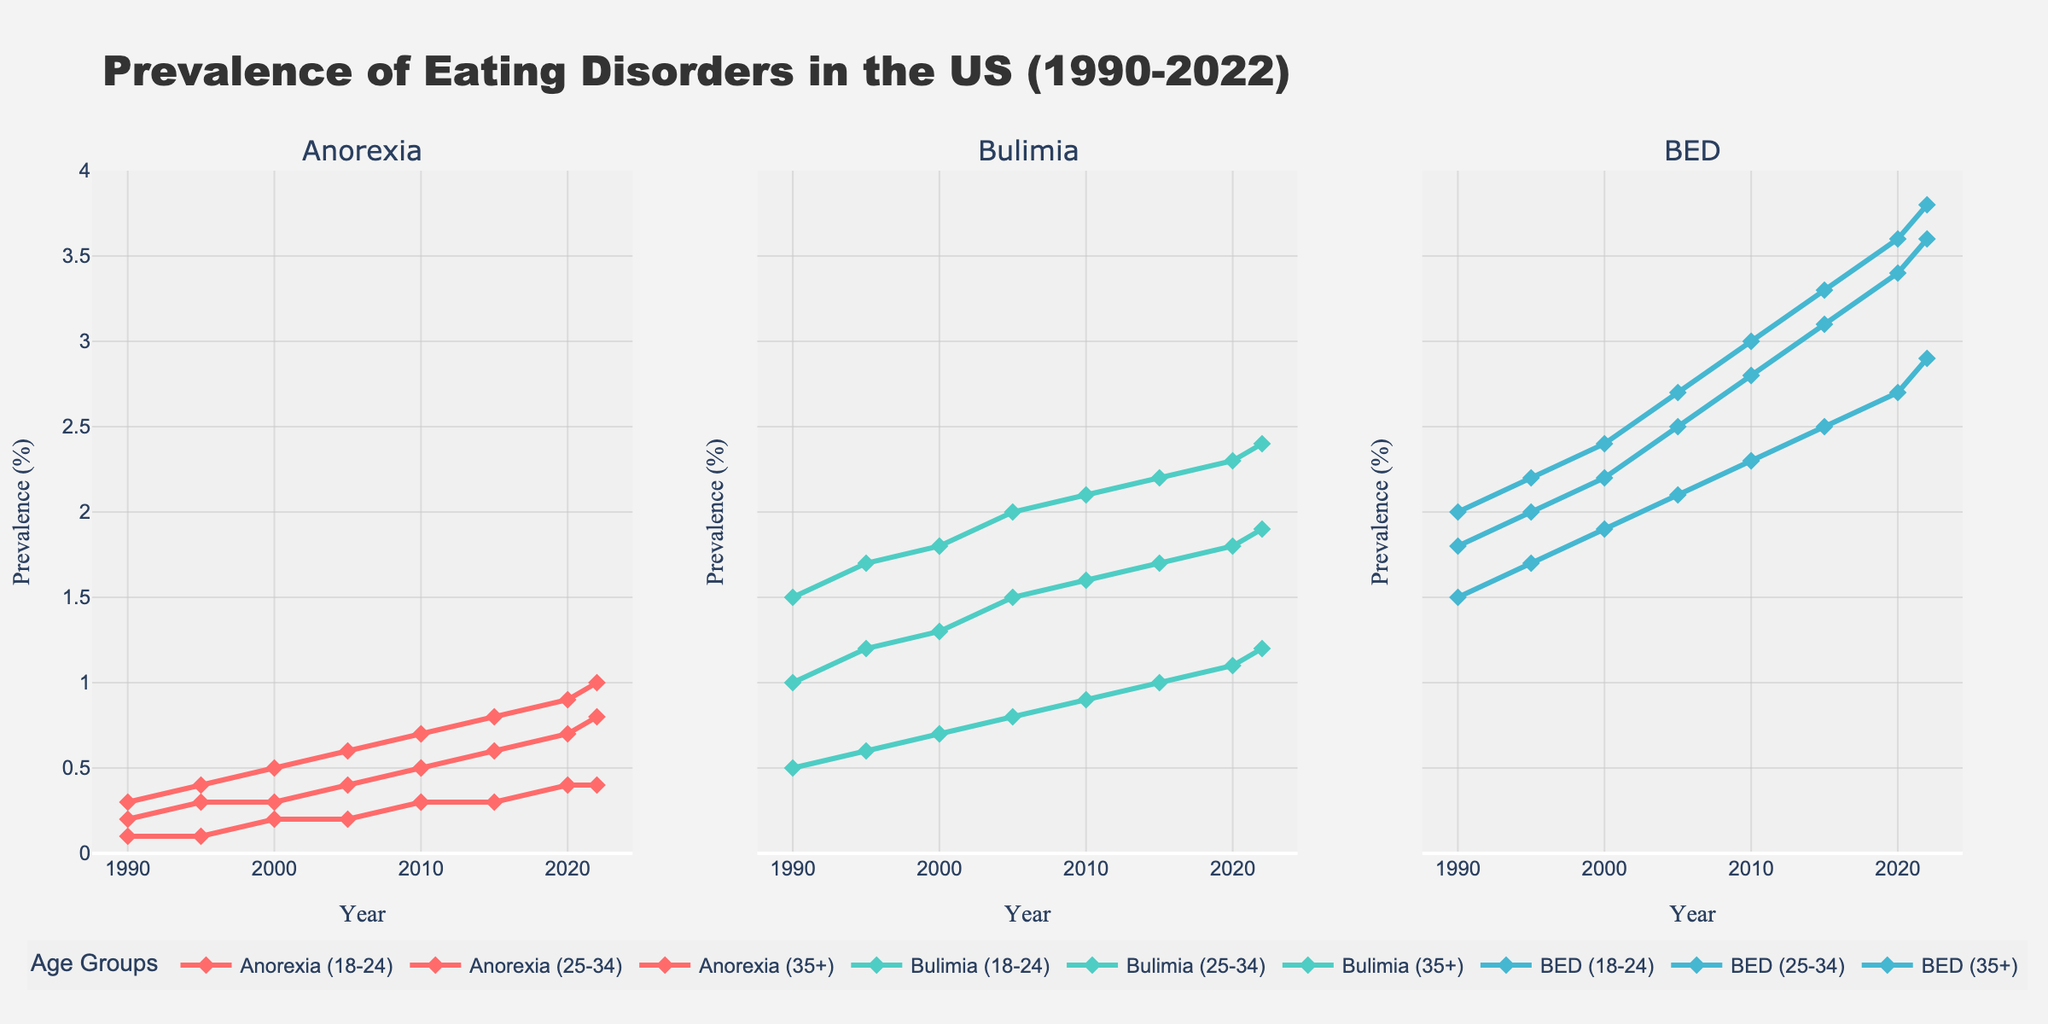What are the trends for Anorexia prevalence among different age groups from 1990 to 2022? To find the trends, look at the lines corresponding to the different age groups in the “Anorexia” subplot. All age groups show an upward trend over the years. Anorexia_18-24 and Anorexia_25-34 have slightly steeper inclines compared to Anorexia_35+.
Answer: Increasing for all age groups In 1995, which eating disorder had the highest prevalence among the 25-34 age group? Check the lines for the year 1995 in the subplot for each eating disorder category for the 25-34 age group. Bulimia_25-34 has the highest prevalence at 1.2%.
Answer: Bulimia What is the rate of increase in BED prevalence for the 18-24 age group from 1990 to 2022? Determine the values for BED_18-24 in 1990 (1.8%) and in 2022 (3.6%). Subtract the earlier value from the later value: 3.6 - 1.8 = 1.8%.
Answer: 1.8% Which age group showed the highest increase in Bulimia prevalence from 1990 to 2022? Compare the differences between the 2022 and 1990 values for Bulimia in each age group. Bulimia_18-24 increased the most from 1.5% to 2.4%, a difference of 0.9%.
Answer: 18-24 Between 2000 and 2010, did the prevalence of Anorexia for the 35+ age group ever exceed 0.3%? Look at the Anorexia_35+ line in the Anorexia subplot between the years 2000 and 2010. The prevalence increases from 0.2% to 0.3% and reaches exactly 0.3% in 2010.
Answer: No Among all age groups and eating disorders in the year 2020, which group had the lowest prevalence? Check the values for all disorder categories and age groups in the year 2020. Anorexia_35+ has the lowest prevalence at 0.4%.
Answer: Anorexia_35+ By how much did the prevalence of Bulimia in the 25-34 age group change from 1990 to 2000? Subtract the Bulimia_25-34 value in 1990 (1.0%) from the value in 2000 (1.3%): 1.3 - 1.0 = 0.3%.
Answer: 0.3% What is the average prevalence of BED in the 25-34 age group from 1990 to 2022? Sum the BED_25-34 values for all years and divide by the number of years [(2.0+2.2+2.4+2.7+3.0+3.3+3.6+3.8) / 8]: (2.0 + 2.2 + 2.4 + 2.7 + 3.0 + 3.3 + 3.6 + 3.8) / 8 = 23.0 / 8 = 2.875%.
Answer: 2.875% Which age group showed the most consistent rise in Anorexia prevalence from 1990 to 2022? Look at the slopes of the lines in the Anorexia subplot. The lines for all age groups generally increase consistently, but the one for Anorexia_18-24 shows the steadiest and constant increase.
Answer: 18-24 How did the prevalence of Anorexia in the 18-24 age group change between 2005 and 2015? Determine the Anorexia_18-24 values in 2005 (0.6%) and in 2015 (0.8%). Subtract the earlier value from the later value: 0.8 - 0.6 = 0.2%.
Answer: 0.2% 